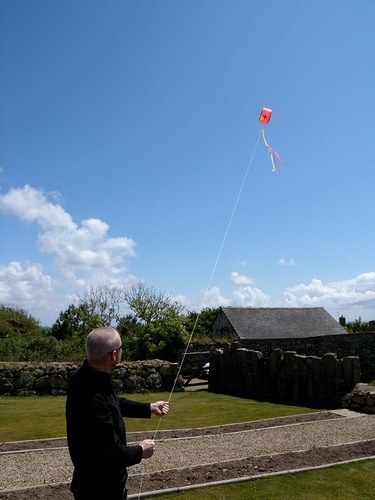Describe the objects in this image and their specific colors. I can see people in blue, black, gray, and darkgray tones and kite in blue, lightblue, darkgray, and salmon tones in this image. 